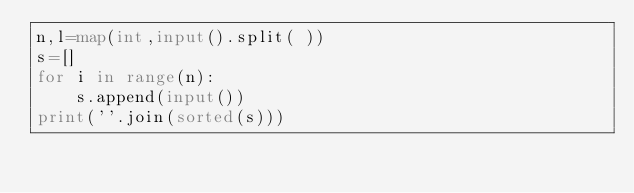Convert code to text. <code><loc_0><loc_0><loc_500><loc_500><_Python_>n,l=map(int,input().split( ))
s=[]
for i in range(n):
    s.append(input())
print(''.join(sorted(s)))
        

</code> 